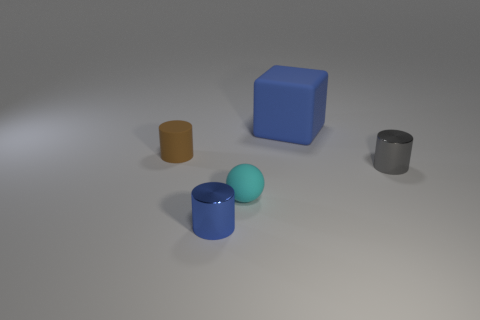Add 5 yellow spheres. How many objects exist? 10 Subtract all cylinders. How many objects are left? 2 Subtract 0 yellow spheres. How many objects are left? 5 Subtract all large blocks. Subtract all tiny cylinders. How many objects are left? 1 Add 5 small brown objects. How many small brown objects are left? 6 Add 1 small brown cylinders. How many small brown cylinders exist? 2 